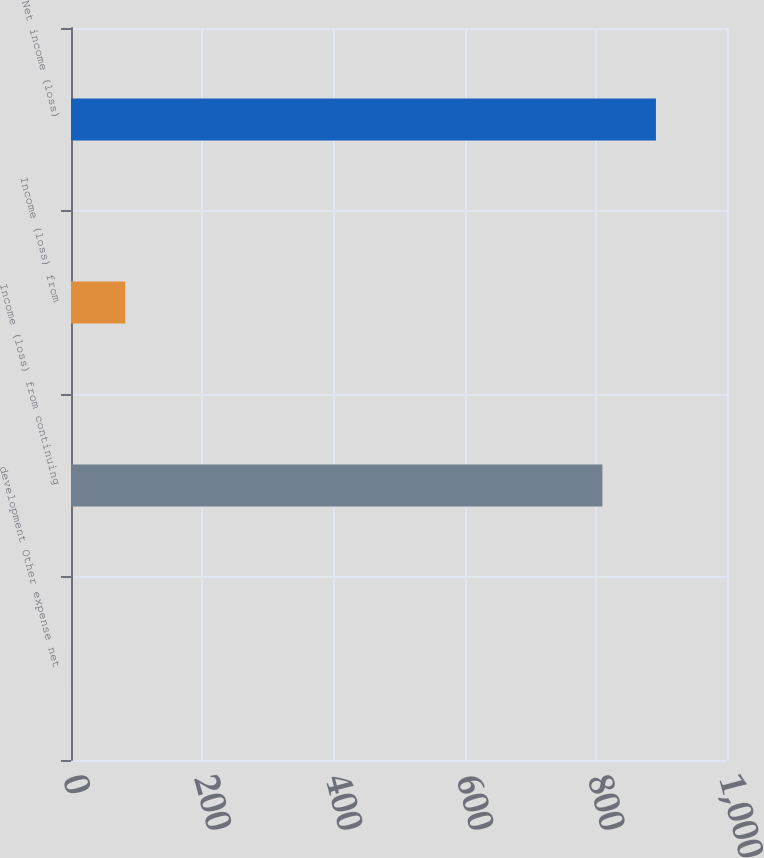<chart> <loc_0><loc_0><loc_500><loc_500><bar_chart><fcel>development Other expense net<fcel>Income (loss) from continuing<fcel>Income (loss) from<fcel>Net income (loss)<nl><fcel>1<fcel>810<fcel>82.7<fcel>891.7<nl></chart> 